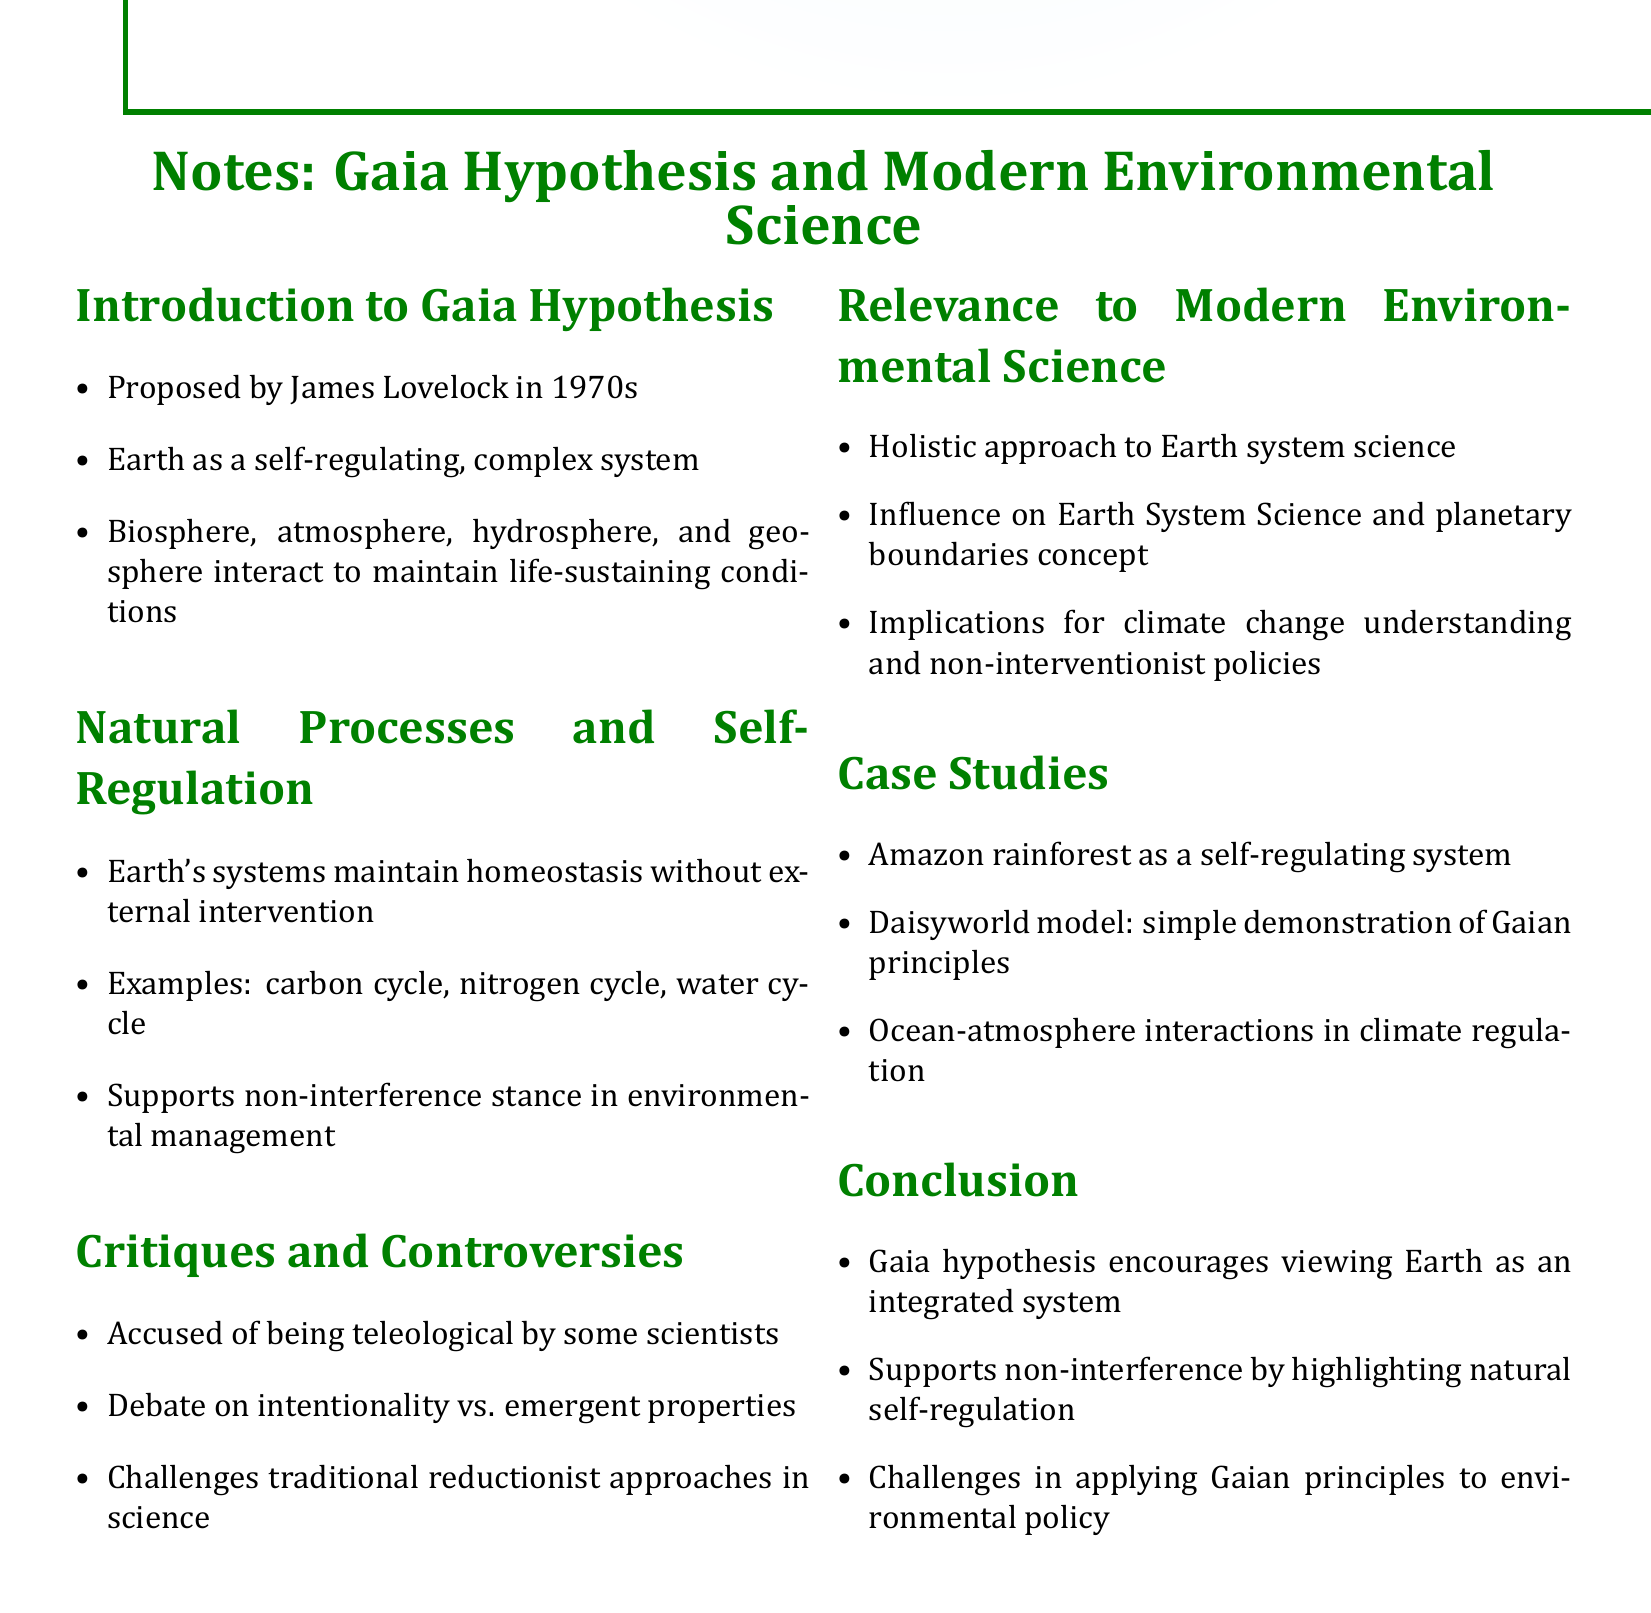What is the title of the document? The title is clearly stated at the beginning of the document, providing a concise overview of the content.
Answer: Notes: Gaia Hypothesis and Modern Environmental Science Who proposed the Gaia Hypothesis? The document mentions that James Lovelock proposed the Gaia Hypothesis in the 1970s.
Answer: James Lovelock What are the main components of Earth's systems in the Gaia Hypothesis? The document lists the biosphere, atmosphere, hydrosphere, and geosphere as components maintaining life-sustaining conditions.
Answer: Biosphere, atmosphere, hydrosphere, and geosphere Which cycles are examples of Earth's natural processes? The document identifies the carbon cycle, nitrogen cycle, and water cycle as natural processes maintaining homeostasis.
Answer: Carbon cycle, nitrogen cycle, water cycle What does Gaia hypothesis encourage regarding the Earth? The conclusion of the document states that it encourages viewing Earth as an integrated system.
Answer: Viewing Earth as an integrated system What is one critique of the Gaia Hypothesis mentioned? The document notes that it has been accused of being teleological by some scientists.
Answer: Teleological What approach does the Gaia hypothesis support in environmental management? The document emphasizes the stance of non-interference in environmental management per the Gaia hypothesis.
Answer: Non-interference What is a case study example used in the document? The document provides examples such as the Amazon rainforest and the Daisyworld model to illustrate Gaian principles.
Answer: Amazon rainforest What does the Gaia hypothesis challenge in science? The document indicates that it challenges traditional reductionist approaches in science.
Answer: Traditional reductionist approaches 